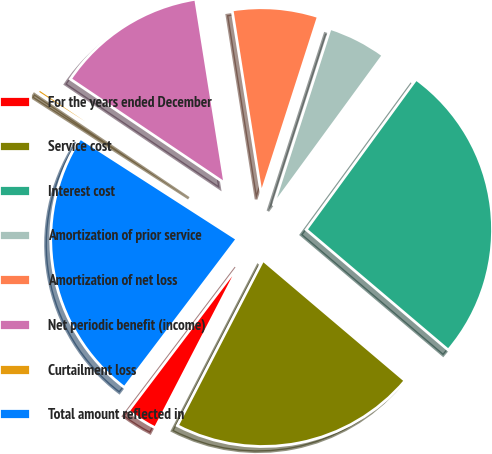Convert chart. <chart><loc_0><loc_0><loc_500><loc_500><pie_chart><fcel>For the years ended December<fcel>Service cost<fcel>Interest cost<fcel>Amortization of prior service<fcel>Amortization of net loss<fcel>Net periodic benefit (income)<fcel>Curtailment loss<fcel>Total amount reflected in<nl><fcel>2.72%<fcel>21.41%<fcel>26.15%<fcel>5.09%<fcel>7.46%<fcel>13.06%<fcel>0.34%<fcel>23.78%<nl></chart> 